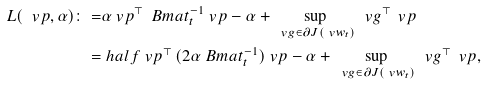<formula> <loc_0><loc_0><loc_500><loc_500>L ( \ v p , \alpha ) \colon = & \alpha \ v p ^ { \top } \, \ B m a t _ { t } ^ { - 1 } \ v p - \alpha + \, \sup _ { \ v g \in \partial J ( \ v w _ { t } ) } \, \ v g ^ { \top } \, \ v p \\ = & \ h a l f \ v p ^ { \top } \, ( 2 \alpha \ B m a t _ { t } ^ { - 1 } ) \ v p - \alpha + \, \sup _ { \ v g \in \partial J ( \ v w _ { t } ) } \, \ v g ^ { \top } \, \ v p ,</formula> 